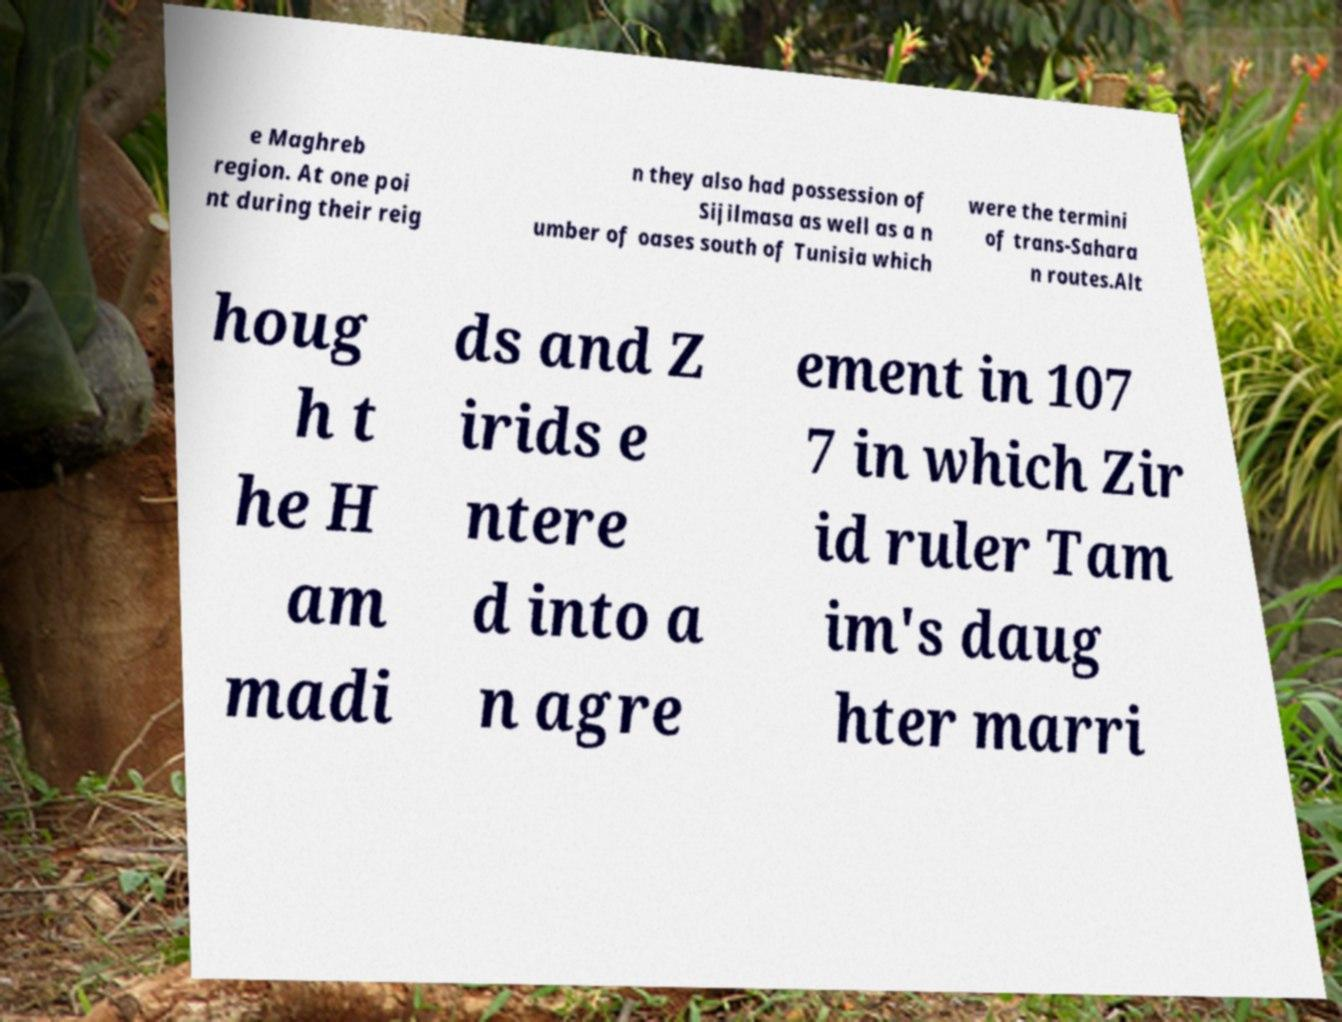For documentation purposes, I need the text within this image transcribed. Could you provide that? e Maghreb region. At one poi nt during their reig n they also had possession of Sijilmasa as well as a n umber of oases south of Tunisia which were the termini of trans-Sahara n routes.Alt houg h t he H am madi ds and Z irids e ntere d into a n agre ement in 107 7 in which Zir id ruler Tam im's daug hter marri 